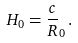<formula> <loc_0><loc_0><loc_500><loc_500>H _ { 0 } = \frac { c } { R } _ { 0 } \, .</formula> 